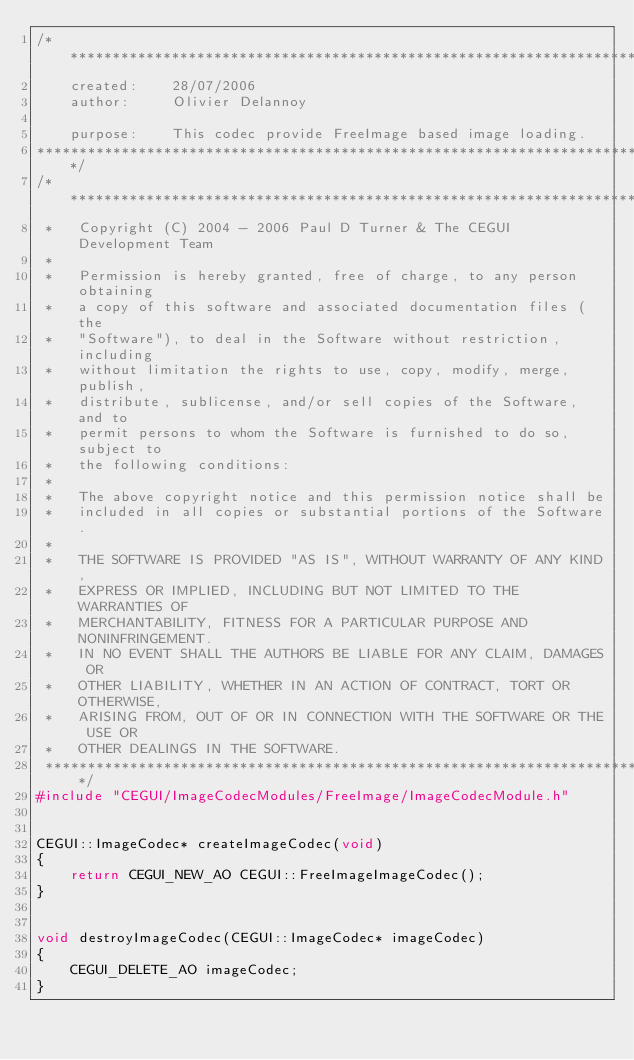<code> <loc_0><loc_0><loc_500><loc_500><_C++_>/***********************************************************************
	created:	28/07/2006
	author:		Olivier Delannoy 
	
	purpose:	This codec provide FreeImage based image loading.  
*************************************************************************/
/***************************************************************************
 *   Copyright (C) 2004 - 2006 Paul D Turner & The CEGUI Development Team
 *
 *   Permission is hereby granted, free of charge, to any person obtaining
 *   a copy of this software and associated documentation files (the
 *   "Software"), to deal in the Software without restriction, including
 *   without limitation the rights to use, copy, modify, merge, publish,
 *   distribute, sublicense, and/or sell copies of the Software, and to
 *   permit persons to whom the Software is furnished to do so, subject to
 *   the following conditions:
 *
 *   The above copyright notice and this permission notice shall be
 *   included in all copies or substantial portions of the Software.
 *
 *   THE SOFTWARE IS PROVIDED "AS IS", WITHOUT WARRANTY OF ANY KIND,
 *   EXPRESS OR IMPLIED, INCLUDING BUT NOT LIMITED TO THE WARRANTIES OF
 *   MERCHANTABILITY, FITNESS FOR A PARTICULAR PURPOSE AND NONINFRINGEMENT.
 *   IN NO EVENT SHALL THE AUTHORS BE LIABLE FOR ANY CLAIM, DAMAGES OR
 *   OTHER LIABILITY, WHETHER IN AN ACTION OF CONTRACT, TORT OR OTHERWISE,
 *   ARISING FROM, OUT OF OR IN CONNECTION WITH THE SOFTWARE OR THE USE OR
 *   OTHER DEALINGS IN THE SOFTWARE.
 ***************************************************************************/
#include "CEGUI/ImageCodecModules/FreeImage/ImageCodecModule.h" 


CEGUI::ImageCodec* createImageCodec(void)
{
    return CEGUI_NEW_AO CEGUI::FreeImageImageCodec();
}


void destroyImageCodec(CEGUI::ImageCodec* imageCodec)
{
    CEGUI_DELETE_AO imageCodec;
}
</code> 